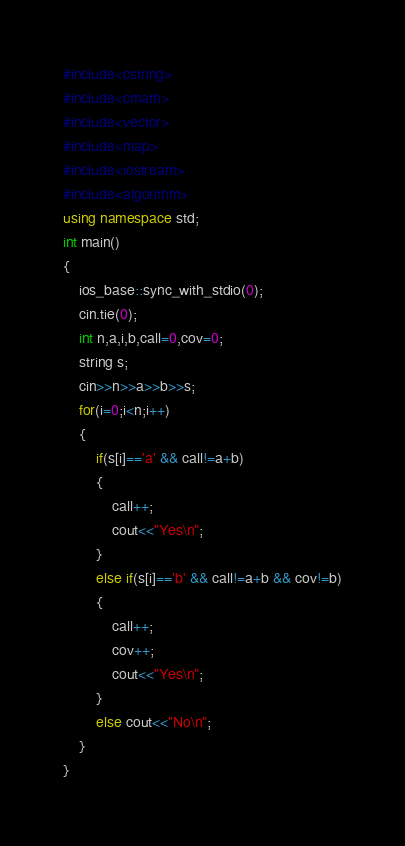Convert code to text. <code><loc_0><loc_0><loc_500><loc_500><_C++_>#include<cstring>
#include<cmath>
#include<vector>
#include<map>
#include<iostream>
#include<algorithm>
using namespace std;
int main()
{
    ios_base::sync_with_stdio(0);
    cin.tie(0);
    int n,a,i,b,call=0,cov=0;
    string s;
    cin>>n>>a>>b>>s;
    for(i=0;i<n;i++)
    {
        if(s[i]=='a' && call!=a+b)
        {
            call++;
            cout<<"Yes\n";
        }
        else if(s[i]=='b' && call!=a+b && cov!=b)
        {
            call++;
            cov++;
            cout<<"Yes\n";
        }
        else cout<<"No\n";
    }
}
</code> 